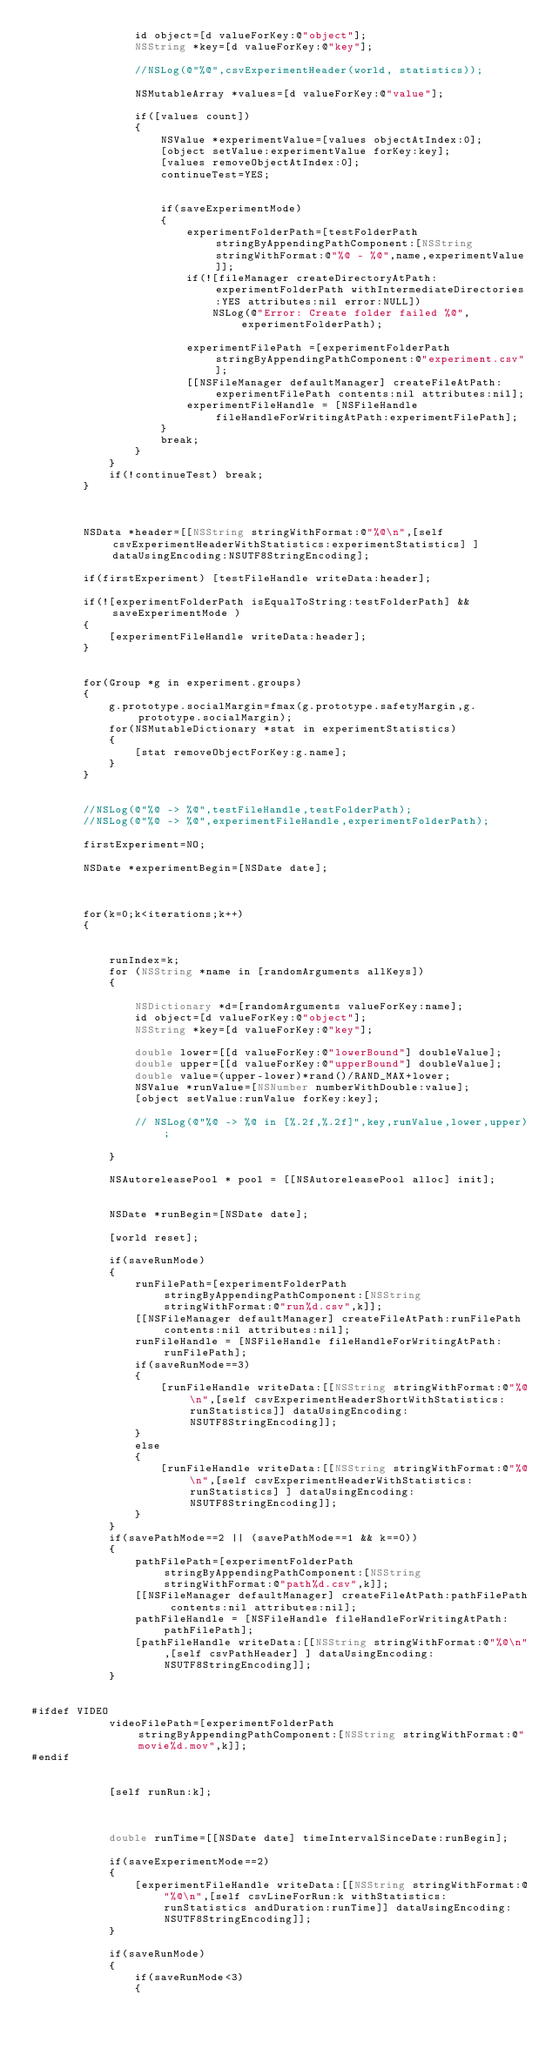<code> <loc_0><loc_0><loc_500><loc_500><_ObjectiveC_>                id object=[d valueForKey:@"object"];
                NSString *key=[d valueForKey:@"key"];
                
                //NSLog(@"%@",csvExperimentHeader(world, statistics));
                
                NSMutableArray *values=[d valueForKey:@"value"];
                
                if([values count])
                {
                    NSValue *experimentValue=[values objectAtIndex:0];
                    [object setValue:experimentValue forKey:key];
                    [values removeObjectAtIndex:0];
                    continueTest=YES;
                    
                    
                    if(saveExperimentMode)
                    {
                        experimentFolderPath=[testFolderPath stringByAppendingPathComponent:[NSString stringWithFormat:@"%@ - %@",name,experimentValue]];
                        if(![fileManager createDirectoryAtPath:experimentFolderPath withIntermediateDirectories:YES attributes:nil error:NULL])
                            NSLog(@"Error: Create folder failed %@", experimentFolderPath);
                        
                        experimentFilePath =[experimentFolderPath stringByAppendingPathComponent:@"experiment.csv"];
                        [[NSFileManager defaultManager] createFileAtPath:experimentFilePath contents:nil attributes:nil];
                        experimentFileHandle = [NSFileHandle fileHandleForWritingAtPath:experimentFilePath];
                    }
                    break;
                }
            }
            if(!continueTest) break;
        }
        
        
        
        NSData *header=[[NSString stringWithFormat:@"%@\n",[self csvExperimentHeaderWithStatistics:experimentStatistics] ] dataUsingEncoding:NSUTF8StringEncoding];
        
        if(firstExperiment) [testFileHandle writeData:header];
        
        if(![experimentFolderPath isEqualToString:testFolderPath] && saveExperimentMode )
        {
            [experimentFileHandle writeData:header];
        }
        
        
        for(Group *g in experiment.groups)
        {
            g.prototype.socialMargin=fmax(g.prototype.safetyMargin,g.prototype.socialMargin);
            for(NSMutableDictionary *stat in experimentStatistics)
            {
                [stat removeObjectForKey:g.name];
            }
        }
        
        
        //NSLog(@"%@ -> %@",testFileHandle,testFolderPath);
        //NSLog(@"%@ -> %@",experimentFileHandle,experimentFolderPath);
        
        firstExperiment=NO;
        
        NSDate *experimentBegin=[NSDate date];
        
        
        
        for(k=0;k<iterations;k++)
        {
            
            
            runIndex=k;
            for (NSString *name in [randomArguments allKeys])
            {
                
                NSDictionary *d=[randomArguments valueForKey:name];
                id object=[d valueForKey:@"object"];
                NSString *key=[d valueForKey:@"key"];
                
                double lower=[[d valueForKey:@"lowerBound"] doubleValue];
                double upper=[[d valueForKey:@"upperBound"] doubleValue];
                double value=(upper-lower)*rand()/RAND_MAX+lower;
                NSValue *runValue=[NSNumber numberWithDouble:value];
                [object setValue:runValue forKey:key];
                
                // NSLog(@"%@ -> %@ in [%.2f,%.2f]",key,runValue,lower,upper);
                
            }
            
            NSAutoreleasePool * pool = [[NSAutoreleasePool alloc] init];
            
            
            NSDate *runBegin=[NSDate date];
            
            [world reset];
            
            if(saveRunMode)
            {
                runFilePath=[experimentFolderPath stringByAppendingPathComponent:[NSString stringWithFormat:@"run%d.csv",k]];
                [[NSFileManager defaultManager] createFileAtPath:runFilePath contents:nil attributes:nil];
                runFileHandle = [NSFileHandle fileHandleForWritingAtPath:runFilePath];
                if(saveRunMode==3)
                {
                    [runFileHandle writeData:[[NSString stringWithFormat:@"%@\n",[self csvExperimentHeaderShortWithStatistics:runStatistics]] dataUsingEncoding:NSUTF8StringEncoding]];
                }
                else
                {
                    [runFileHandle writeData:[[NSString stringWithFormat:@"%@\n",[self csvExperimentHeaderWithStatistics:runStatistics] ] dataUsingEncoding:NSUTF8StringEncoding]];
                }
            }
            if(savePathMode==2 || (savePathMode==1 && k==0))
            {
                pathFilePath=[experimentFolderPath stringByAppendingPathComponent:[NSString stringWithFormat:@"path%d.csv",k]];
                [[NSFileManager defaultManager] createFileAtPath:pathFilePath contents:nil attributes:nil];
                pathFileHandle = [NSFileHandle fileHandleForWritingAtPath:pathFilePath];
                [pathFileHandle writeData:[[NSString stringWithFormat:@"%@\n",[self csvPathHeader] ] dataUsingEncoding:NSUTF8StringEncoding]];
            }
            
            
#ifdef VIDEO
            videoFilePath=[experimentFolderPath stringByAppendingPathComponent:[NSString stringWithFormat:@"movie%d.mov",k]];
#endif
            
            
            [self runRun:k];
            
            
            
            double runTime=[[NSDate date] timeIntervalSinceDate:runBegin];
            
            if(saveExperimentMode==2)
            {
                [experimentFileHandle writeData:[[NSString stringWithFormat:@"%@\n",[self csvLineForRun:k withStatistics:runStatistics andDuration:runTime]] dataUsingEncoding:NSUTF8StringEncoding]];
            }
            
            if(saveRunMode)
            {
                if(saveRunMode<3)
                {</code> 